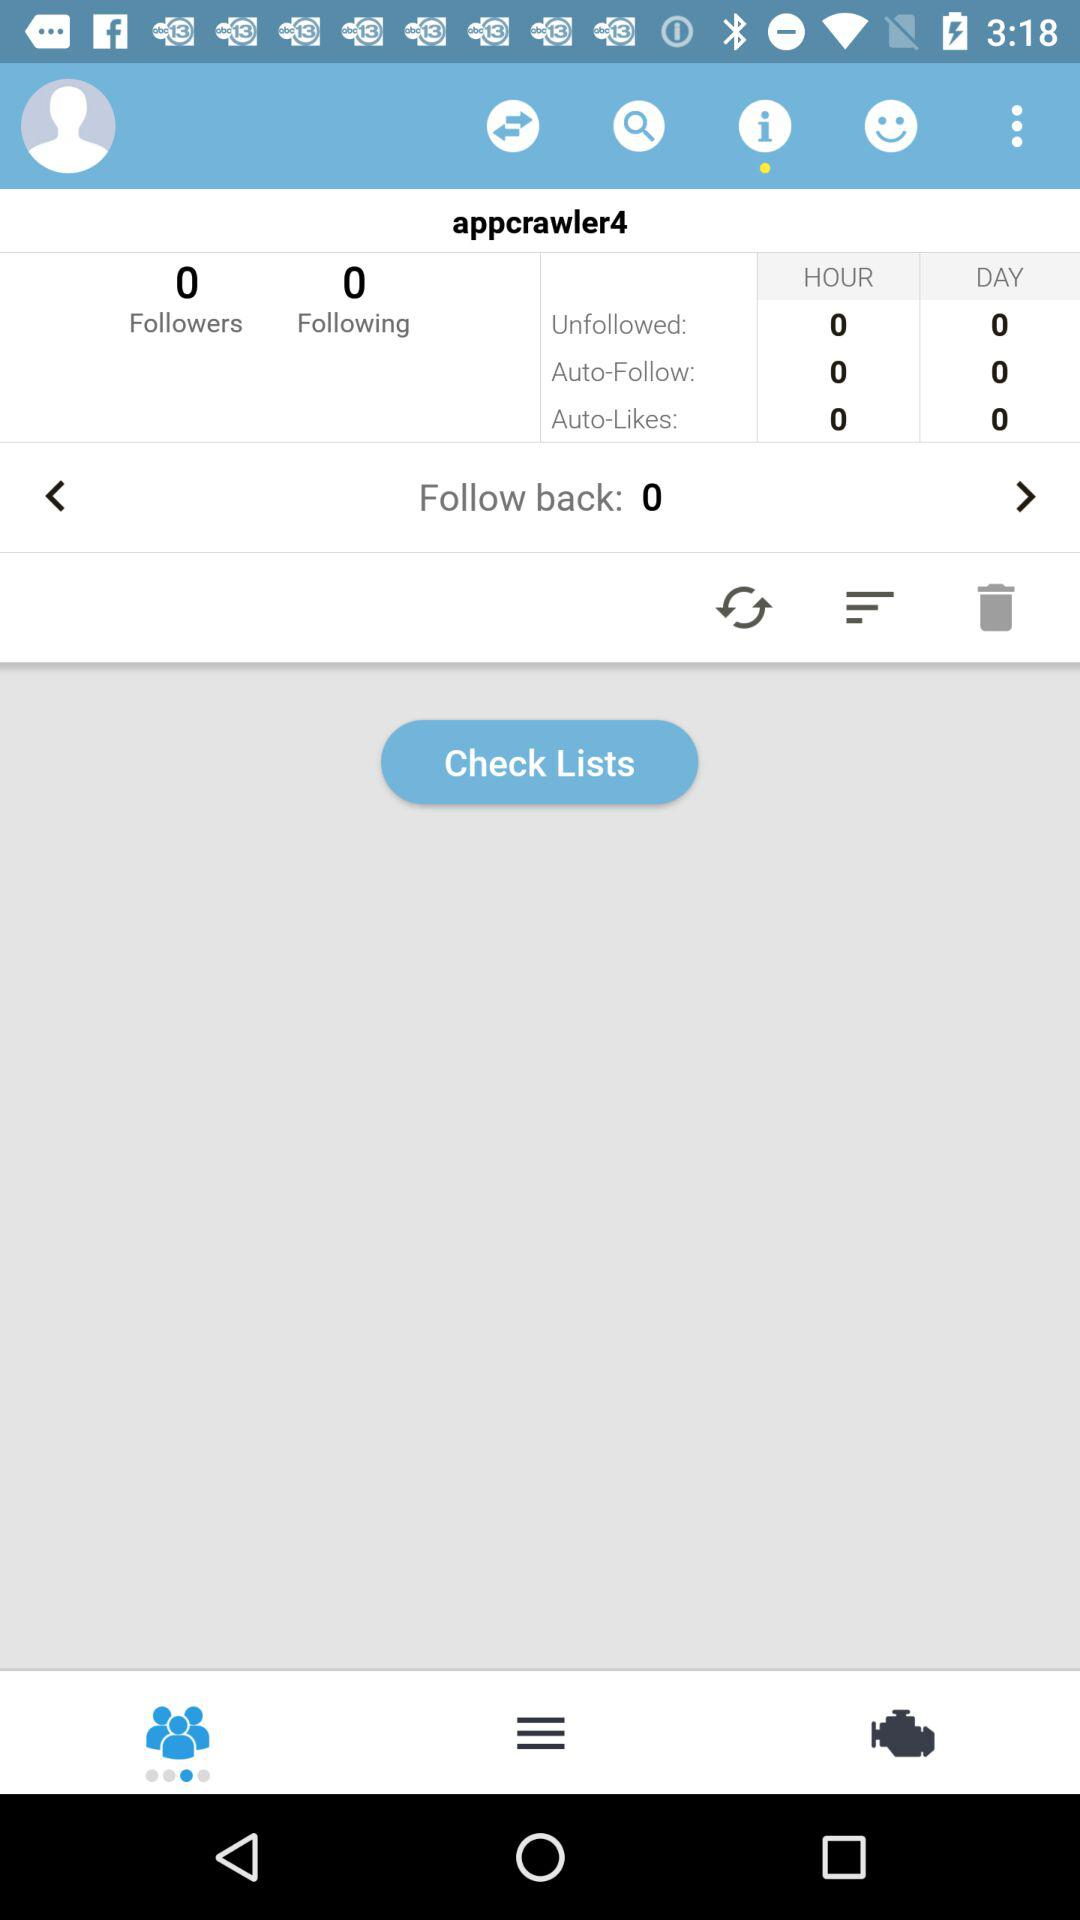What's the total count of followers? The total count of followers is 0. 